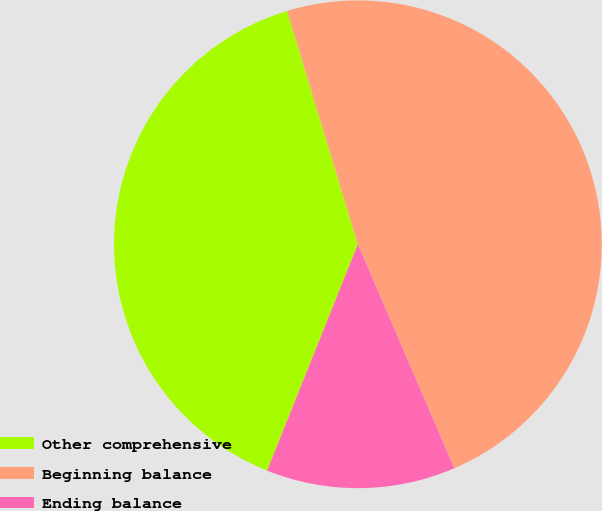<chart> <loc_0><loc_0><loc_500><loc_500><pie_chart><fcel>Other comprehensive<fcel>Beginning balance<fcel>Ending balance<nl><fcel>39.24%<fcel>48.22%<fcel>12.54%<nl></chart> 